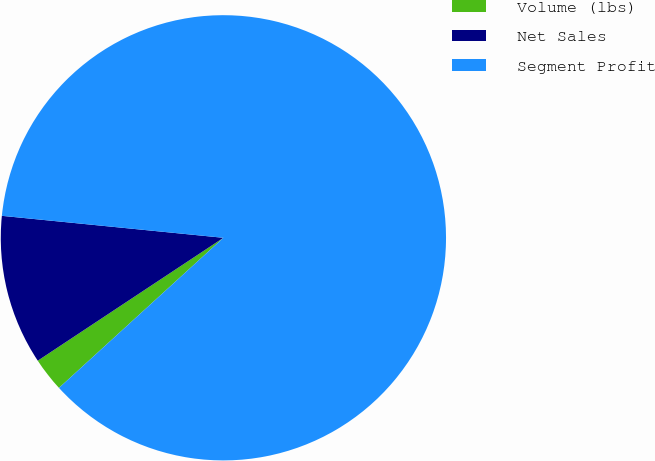Convert chart to OTSL. <chart><loc_0><loc_0><loc_500><loc_500><pie_chart><fcel>Volume (lbs)<fcel>Net Sales<fcel>Segment Profit<nl><fcel>2.47%<fcel>10.88%<fcel>86.65%<nl></chart> 